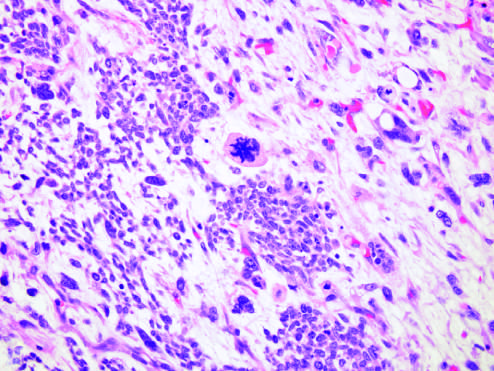what was present in other areas within this wilms tumor, characterized by cells with hyperchromatic, pleomorphic nuclei, and an abnormal mitosis (center of field)?
Answer the question using a single word or phrase. Focal anaplasia 